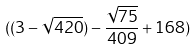<formula> <loc_0><loc_0><loc_500><loc_500>( ( 3 - \sqrt { 4 2 0 } ) - \frac { \sqrt { 7 5 } } { 4 0 9 } + 1 6 8 )</formula> 